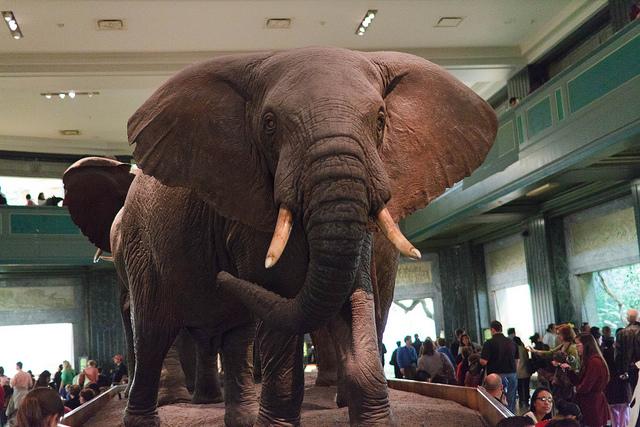What kind of setting is this?
Give a very brief answer. Museum. Is this elephant alive?
Short answer required. No. Are the elephants face to face?
Concise answer only. No. 